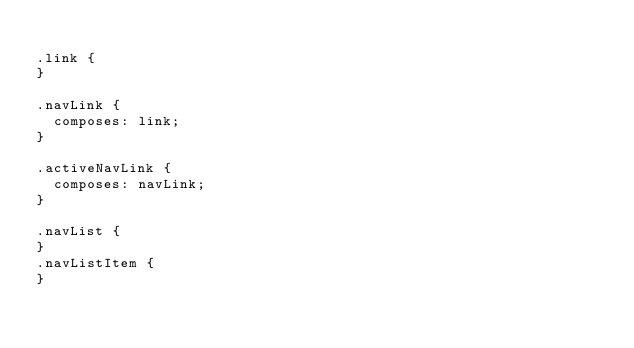<code> <loc_0><loc_0><loc_500><loc_500><_CSS_>
.link {
}

.navLink {
  composes: link;
}

.activeNavLink {
  composes: navLink;
}

.navList {
}
.navListItem {
}
</code> 